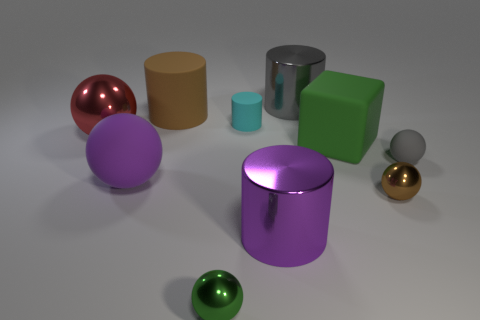Subtract all small green balls. How many balls are left? 4 Subtract all red balls. How many balls are left? 4 Subtract all cyan spheres. Subtract all cyan cylinders. How many spheres are left? 5 Subtract all cubes. How many objects are left? 9 Add 1 red objects. How many red objects are left? 2 Add 5 cyan rubber cylinders. How many cyan rubber cylinders exist? 6 Subtract 0 yellow blocks. How many objects are left? 10 Subtract all brown metallic spheres. Subtract all small objects. How many objects are left? 5 